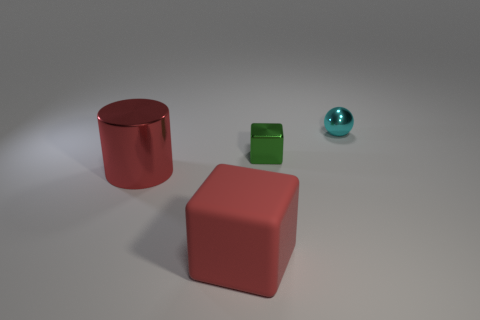Is there any other thing that has the same color as the matte object?
Provide a short and direct response. Yes. There is a red thing to the left of the red rubber block; is it the same size as the tiny cyan thing?
Provide a succinct answer. No. There is a metal thing in front of the tiny metal block; how many large red rubber things are behind it?
Provide a succinct answer. 0. There is a tiny shiny thing right of the small shiny thing to the left of the small shiny ball; are there any big metal cylinders that are behind it?
Your answer should be compact. No. There is a red object that is the same shape as the small green metal thing; what is it made of?
Offer a very short reply. Rubber. Is there anything else that has the same material as the cylinder?
Your answer should be compact. Yes. Are the small green thing and the cube that is in front of the red cylinder made of the same material?
Offer a terse response. No. What shape is the tiny metallic object that is to the right of the cube behind the large red metallic cylinder?
Your answer should be very brief. Sphere. What number of small things are red cylinders or red objects?
Provide a succinct answer. 0. How many other large rubber objects have the same shape as the green thing?
Offer a terse response. 1. 